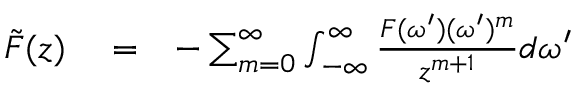<formula> <loc_0><loc_0><loc_500><loc_500>\begin{array} { r l r } { \tilde { F } ( z ) } & = } & { - \sum _ { m = 0 } ^ { \infty } \int _ { - \infty } ^ { \infty } \frac { F ( \omega ^ { \prime } ) ( \omega ^ { \prime } ) ^ { m } } { z ^ { m + 1 } } d \omega ^ { \prime } } \end{array}</formula> 